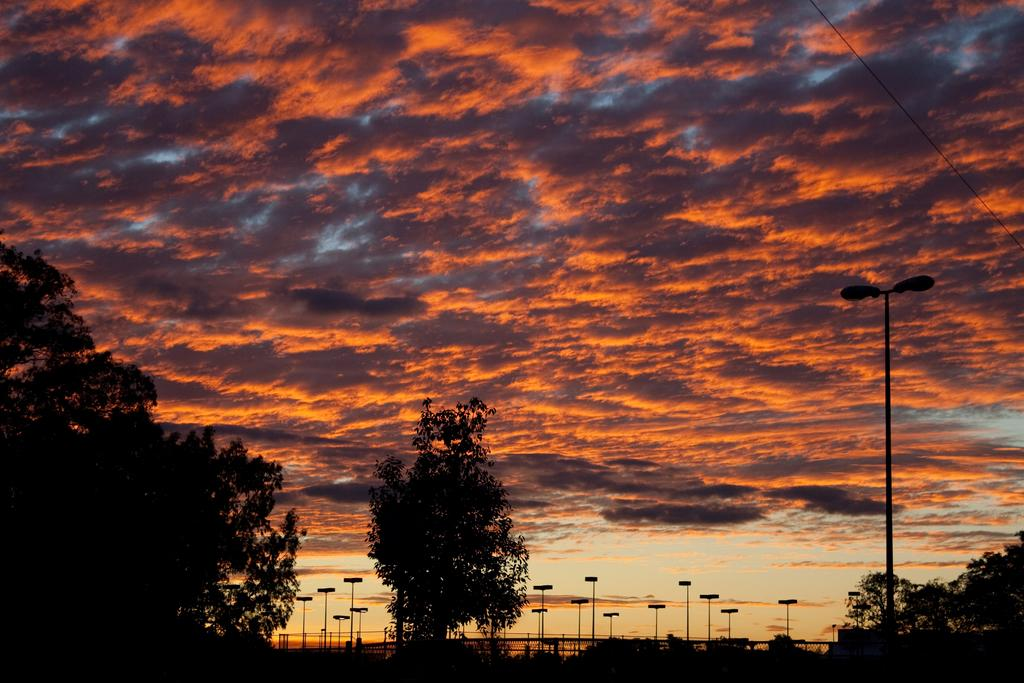At what time of day was the picture taken? The picture was taken during the evening. What can be seen in the foreground of the image? There are trees and street lights in the foreground of the image. What is the condition of the sky in the image? The sky is cloudy in the image. What is present on the right side of the image? There is a cable on the right side of the image. How many roses are visible in the image? There are no roses present in the image. What is the weight of the line in the image? There is no line present in the image, so it is not possible to determine its weight. 